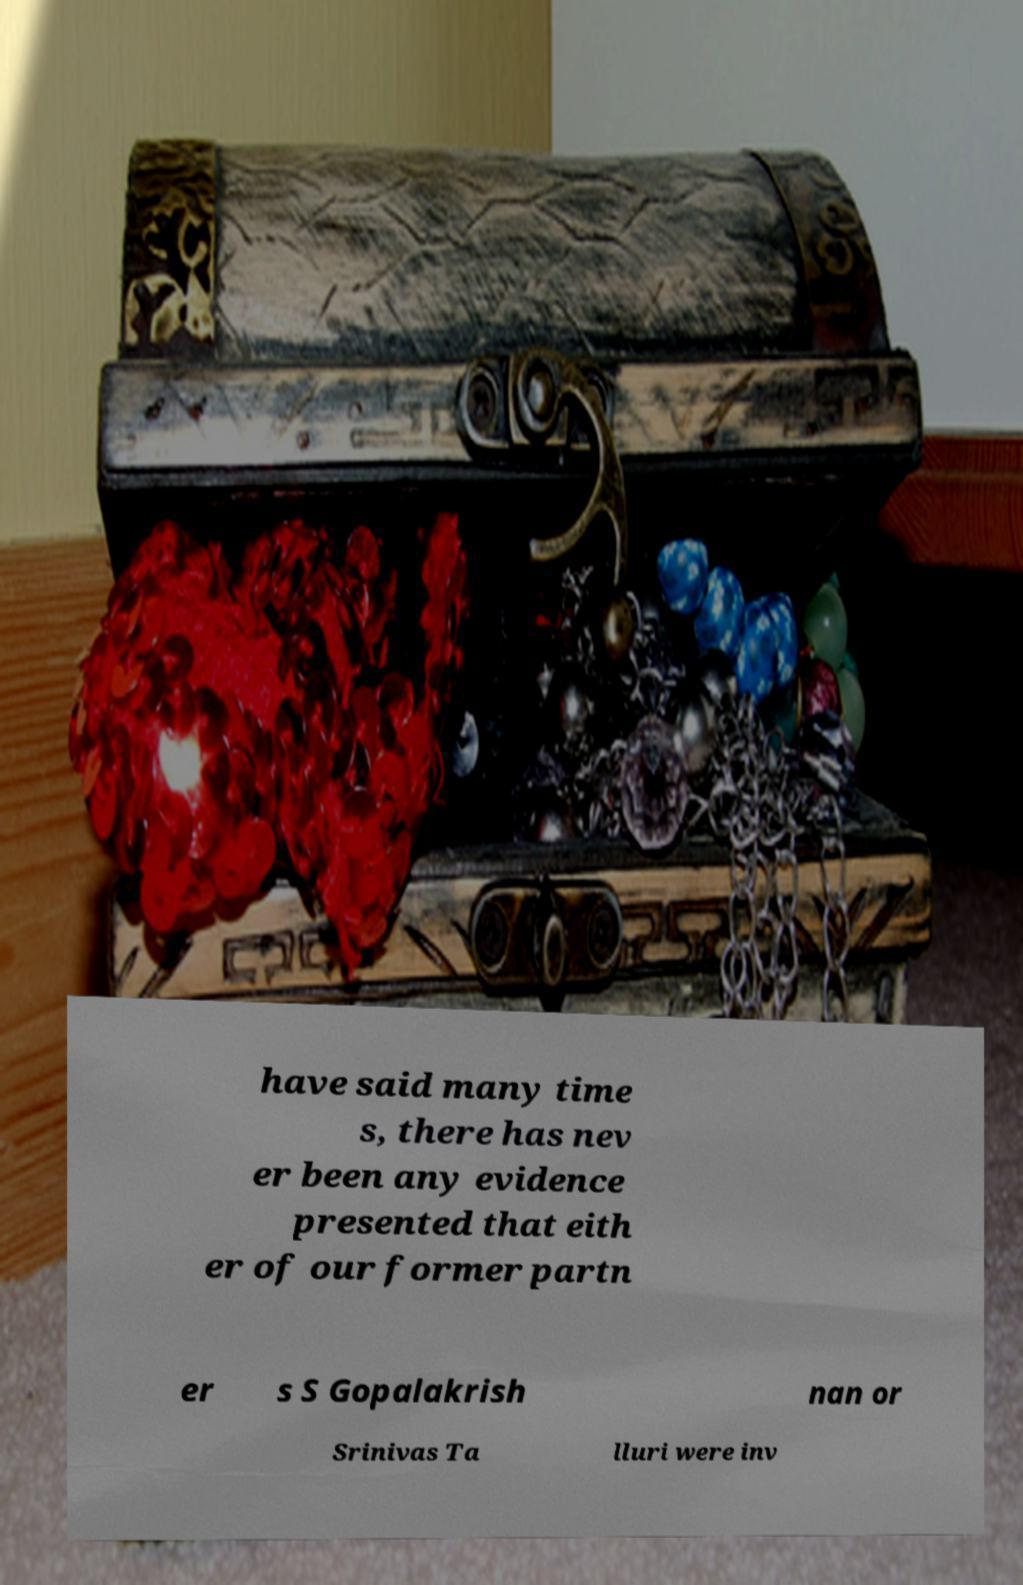Could you extract and type out the text from this image? have said many time s, there has nev er been any evidence presented that eith er of our former partn er s S Gopalakrish nan or Srinivas Ta lluri were inv 